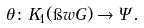<formula> <loc_0><loc_0><loc_500><loc_500>\theta \colon K _ { 1 } ( \i w { G } ) \rightarrow \Psi .</formula> 